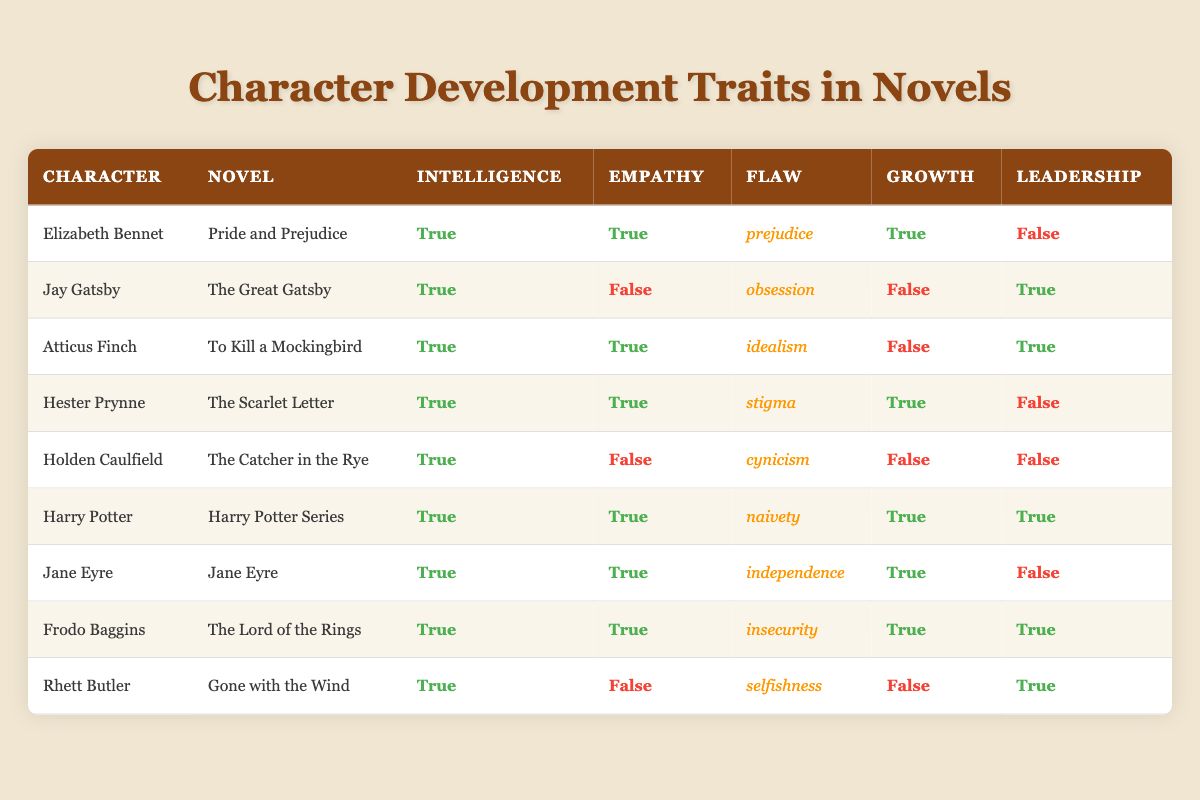What are the traits of Elizabeth Bennet? According to the table, Elizabeth Bennet has the traits of intelligence (True), empathy (True), a flaw of prejudice, personal growth (True), and does not exhibit leadership (False).
Answer: Intelligence: True, Empathy: True, Flaw: prejudice, Growth: True, Leadership: False Which characters show personal growth? From the table, the characters that exhibit personal growth are Elizabeth Bennet, Hester Prynne, Harry Potter, Jane Eyre, and Frodo Baggins. This is determined by checking the growth column for True values.
Answer: Elizabeth Bennet, Hester Prynne, Harry Potter, Jane Eyre, Frodo Baggins Is Jay Gatsby a character with empathy? Looking at Jay Gatsby's traits in the table, he has a value of False under empathy, meaning he lacks empathy.
Answer: No How many characters exhibit both intelligence and leadership? By examining the table, the characters who demonstrate both intelligence (True) and leadership (True) are Jay Gatsby, Atticus Finch, Harry Potter, Frodo Baggins, and Rhett Butler. There are a total of 5 characters.
Answer: 5 Which character has the flaw of insecurity and shows growth? The table indicates that Frodo Baggins has the flaw of insecurity and also shows personal growth (True). To find this, we look at the flaw column and the growth column together.
Answer: Frodo Baggins What is the average number of characters with intelligence? Every character listed in the table possesses intelligence, which means we have 9 characters with a True value under intelligence. Therefore, the average is 9 out of 9, which is 1, indicating all characters exhibit intelligence.
Answer: 1 Do any characters have the flaw of obsession? From the table, Jay Gatsby is the only character listed with the flaw of obsession. This is determined by finding the value in the flaw column.
Answer: Yes Which character has both the flaw of naivety and shows leadership? After checking the table, Harry Potter is the only character listed with a flaw of naivety and shows leadership with a True value. Therefore, the only answer is Harry Potter.
Answer: Harry Potter How many characters lack empathy? Observing the table, Holden Caulfield, Jay Gatsby, Atticus Finch, and Rhett Butler are the characters listed with False under empathy, which adds up to 4 characters lacking empathy.
Answer: 4 